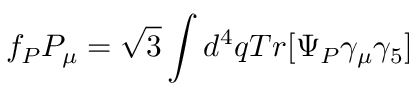<formula> <loc_0><loc_0><loc_500><loc_500>f _ { P } P _ { \mu } = \sqrt { 3 } \int d ^ { 4 } q T r [ \Psi _ { P } \gamma _ { \mu } \gamma _ { 5 } ]</formula> 